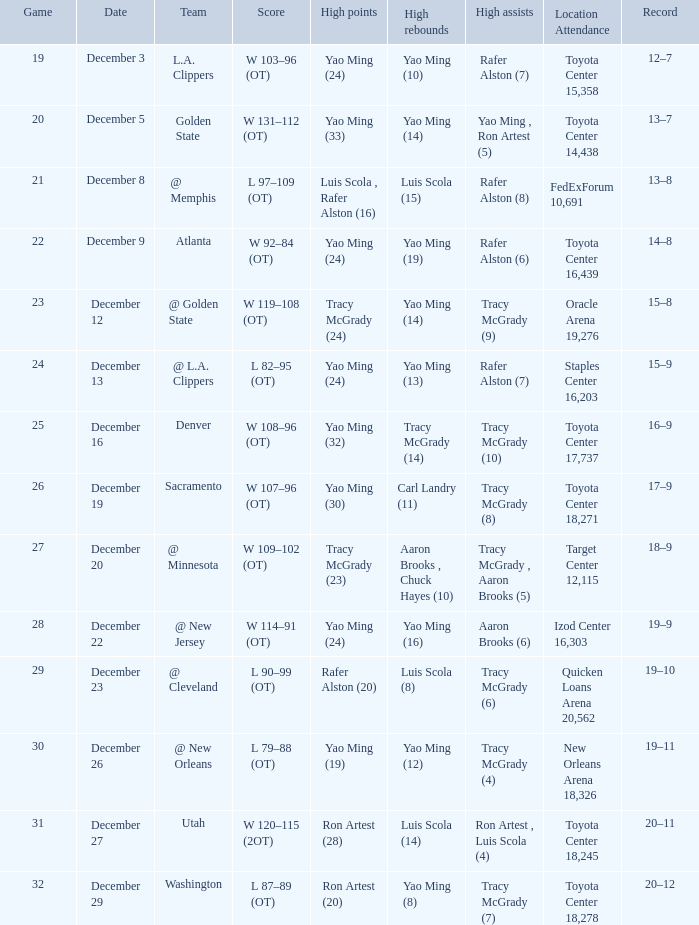When @ new orleans is the team possessing the highest quantity of rebounds? Yao Ming (12). 